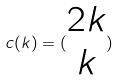Convert formula to latex. <formula><loc_0><loc_0><loc_500><loc_500>c ( k ) = ( \begin{matrix} 2 k \\ k \end{matrix} )</formula> 